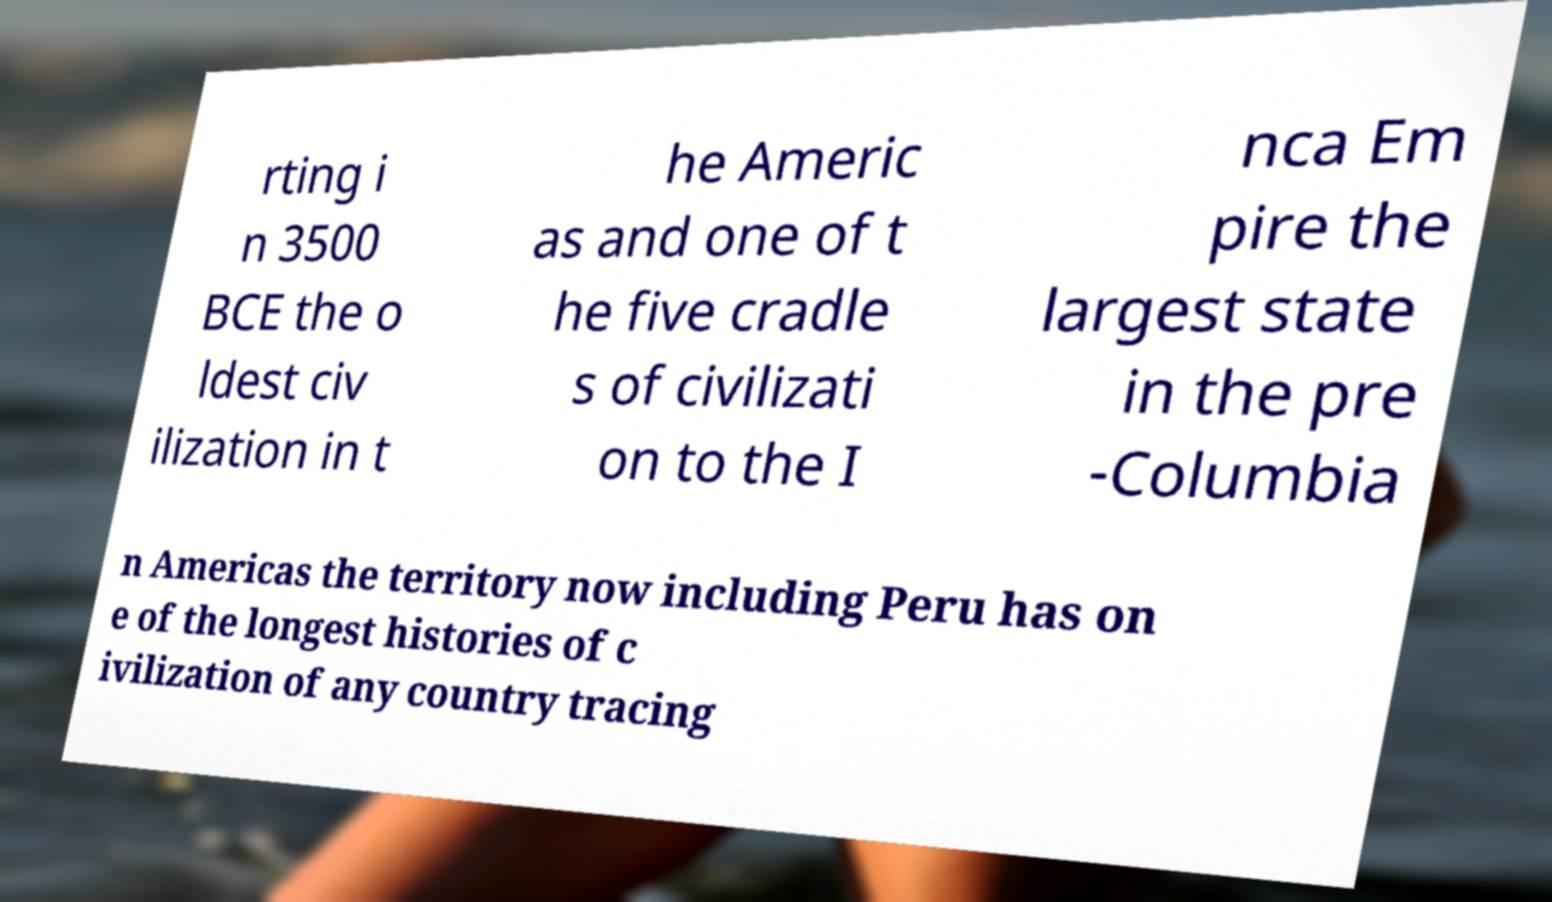Can you accurately transcribe the text from the provided image for me? rting i n 3500 BCE the o ldest civ ilization in t he Americ as and one of t he five cradle s of civilizati on to the I nca Em pire the largest state in the pre -Columbia n Americas the territory now including Peru has on e of the longest histories of c ivilization of any country tracing 